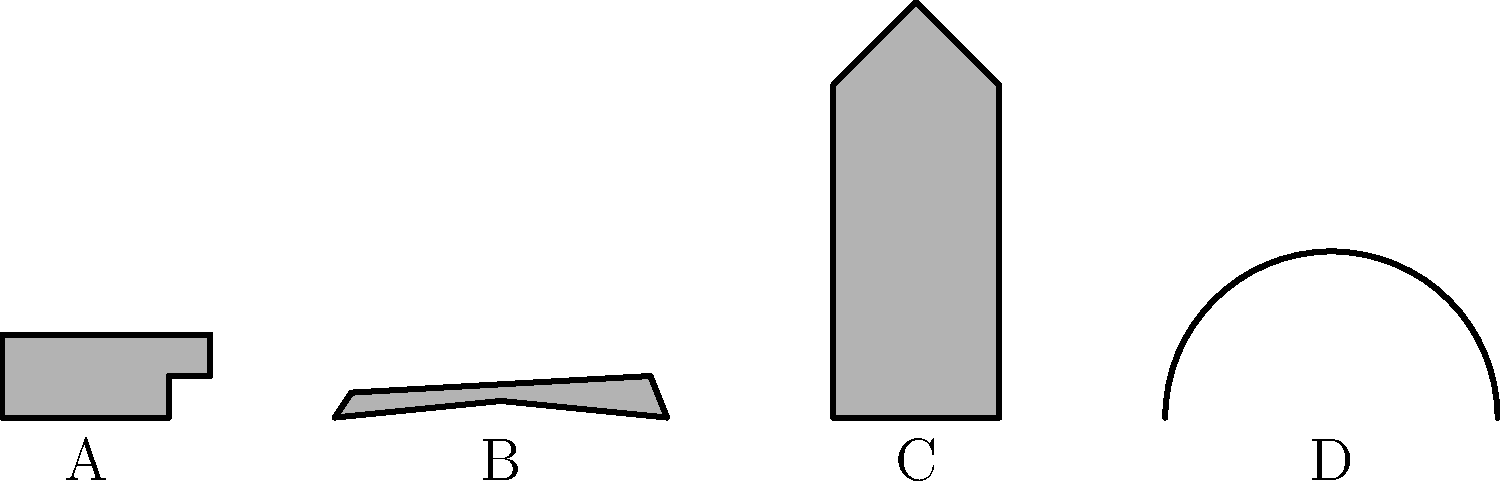Match the iconic action movie weapons shown as silhouettes to their corresponding films:

A. __________ (James Bond series)
B. __________ (Kill Bill)
C. __________ (Star Wars)
D. __________ (Indiana Jones series) Step 1: Identify the silhouettes
A. This silhouette represents a handgun, likely a pistol.
B. This shape resembles a sword, specifically a katana.
C. This long, cylindrical object with a slight flare at the top is characteristic of a lightsaber.
D. The curved line represents a whip.

Step 2: Match weapons to films
A. The James Bond series is known for its sophisticated spy gadgets, with the Walther PPK pistol being Bond's signature weapon.
B. In Kill Bill, the protagonist uses a katana (Japanese sword) as her primary weapon throughout her quest for revenge.
C. Star Wars is famous for its lightsabers, energy sword weapons used by Jedi and Sith.
D. Indiana Jones is well-known for using a bullwhip as both a tool and a weapon in his adventures.

Step 3: Fill in the blanks
A. Pistol (James Bond series)
B. Katana (Kill Bill)
C. Lightsaber (Star Wars)
D. Whip (Indiana Jones series)
Answer: A. Pistol, B. Katana, C. Lightsaber, D. Whip 